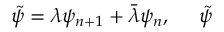Convert formula to latex. <formula><loc_0><loc_0><loc_500><loc_500>\tilde { \psi } = \lambda \psi _ { n + 1 } + \bar { \lambda } \psi _ { n } , \, \tilde { \psi }</formula> 